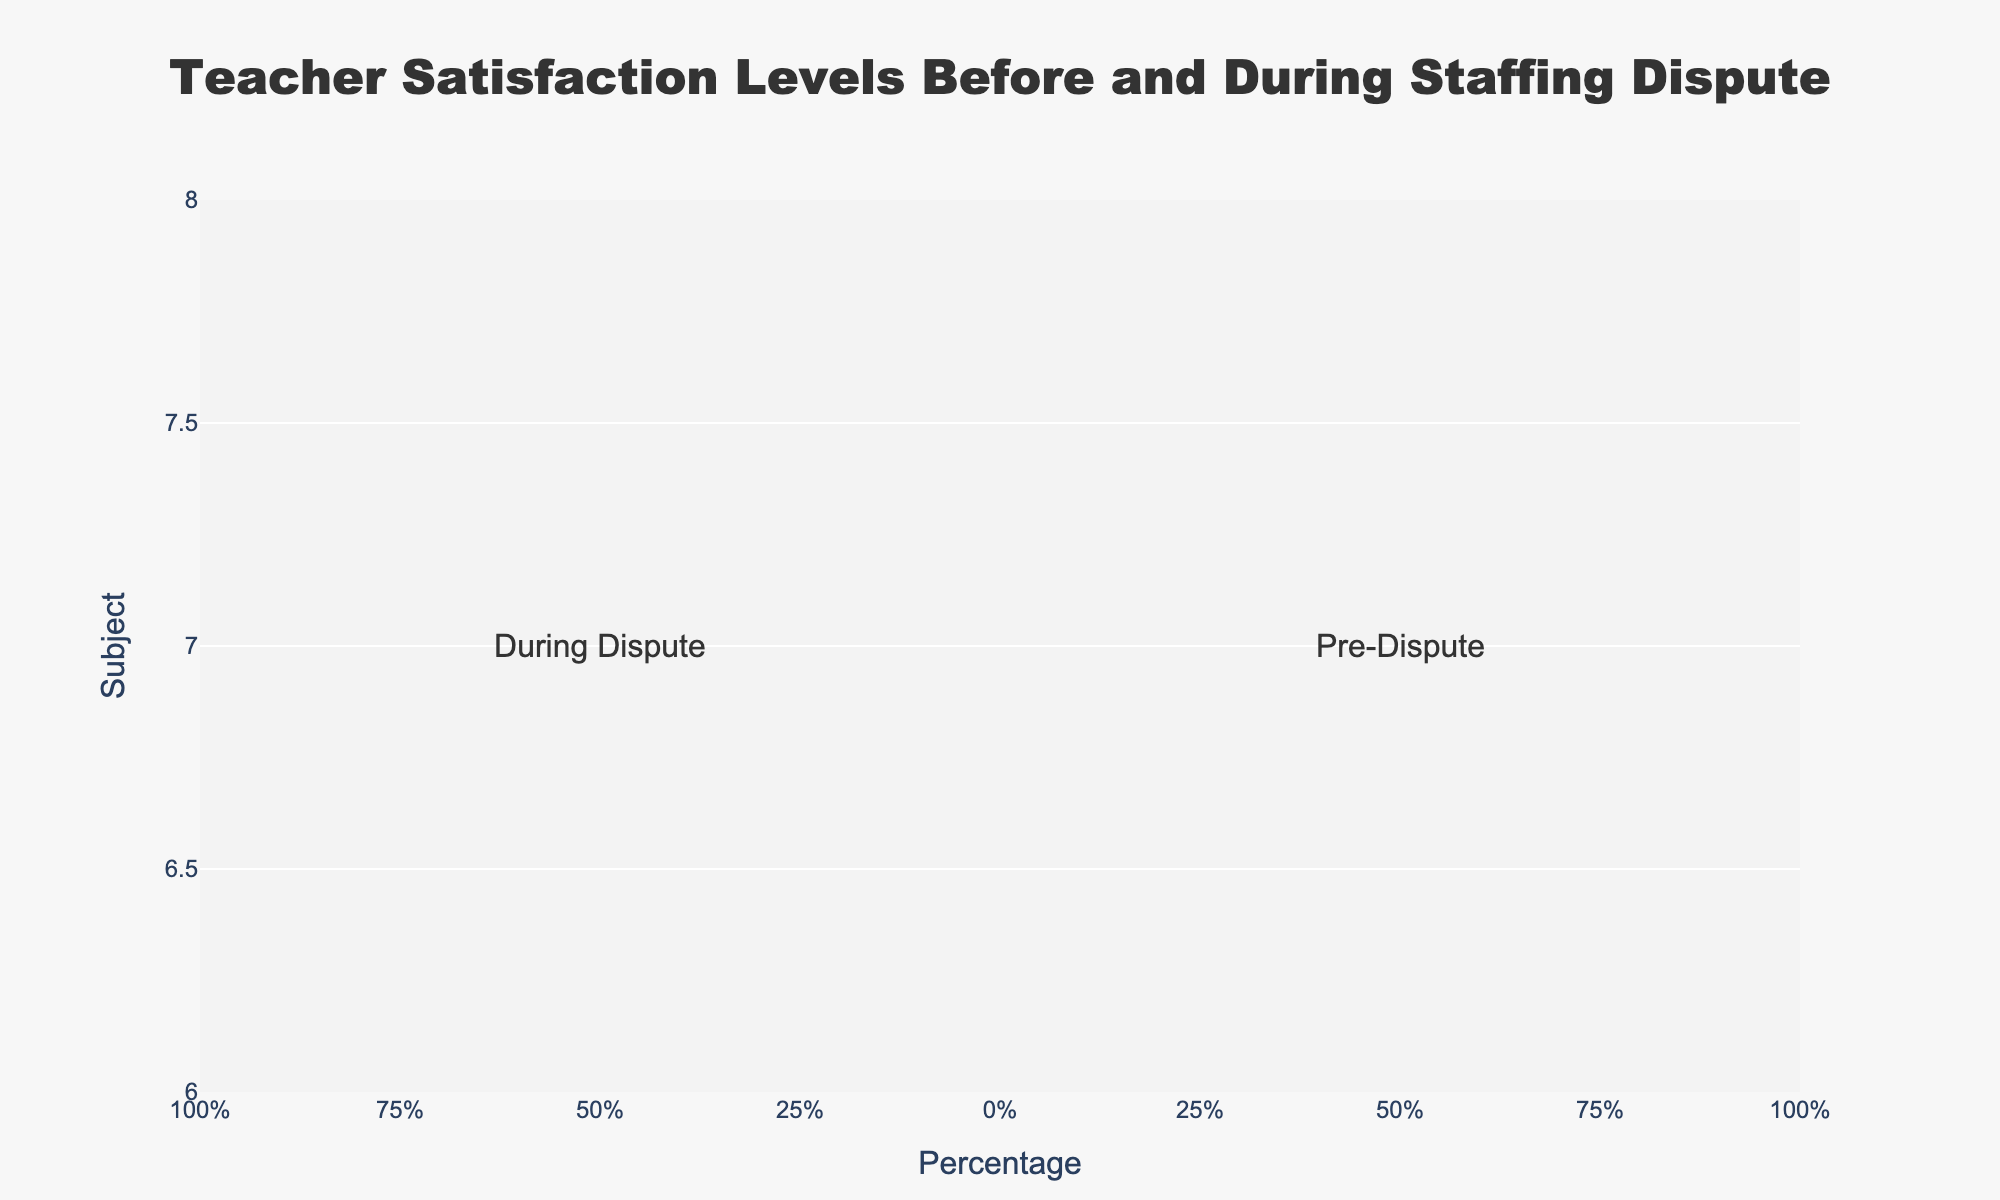Which subject had the highest percentage of teachers "Very Dissatisfied" during the dispute? Look at the "Very Dissatisfied" category for the "During Dispute" section of each subject. The highest bar belongs to Science.
Answer: Science Which subject saw the largest increase in "Very Dissatisfied" teachers from pre-dispute to during the dispute? Calculate the difference in "Very Dissatisfied" percentages between "Pre-Dispute" and "During Dispute" for each subject. The biggest increase (20-5) is in English.
Answer: English What is the total percentage of English teachers who were satisfied or very satisfied during the dispute? Add the percentages of "Satisfied" and "Very Satisfied" categories for English during the dispute: 20% + 10% = 30%.
Answer: 30% Comparing the pre-dispute and during dispute periods, which satisfaction level saw the most significant decrease across all subjects? The "Satisfied" category experienced the most significant decrease, by looking at the overall trend where the "Satisfied" bars are much smaller during the dispute.
Answer: Satisfied How many total percentage points did the "Satisfied" and "Very Satisfied" categories drop for Math from pre-dispute to during the dispute? For Math: "Satisfied" dropped from 45% to 22% (45-22) and "Very Satisfied" from 18% to 8% (18-8). Sum of drops: (45-22) + (18-8) = 33 points.
Answer: 33 points Which category experienced the least amount of change for Physical Education teachers from pre-dispute to during the dispute? The "Neutral" category had the least change for Physical Education, with a small percentage difference (30% during the dispute vs. 22% pre-dispute).
Answer: Neutral Compare the percentage of "Neutral" teachers in Art before and during the dispute. Is it higher or lower during the dispute? Pre-Dispute "Neutral" for Art is 23%, During Dispute is 31%. Since 31% is greater than 23%, it's higher.
Answer: Higher What percentage of teachers were dissatisfied (Very Dissatisfied + Dissatisfied) in History during the dispute? Add the percentages of "Very Dissatisfied" and "Dissatisfied" for History during the dispute: 17% + 23% = 40%.
Answer: 40% Which subject had the highest total percentage of satisfied (Satisfied + Very Satisfied) teachers pre-dispute? Add the percentages of "Satisfied" and "Very Satisfied" for each subject pre-dispute. Physical Education has the highest with 50% + 14% = 64%.
Answer: Physical Education By how much did the percentage of "Very Dissatisfied" Science teachers change from pre-dispute to during the dispute? Subtract the "Very Dissatisfied" percentage pre-dispute from during the dispute for Science: 20% - 8% = 12%.
Answer: 12% 